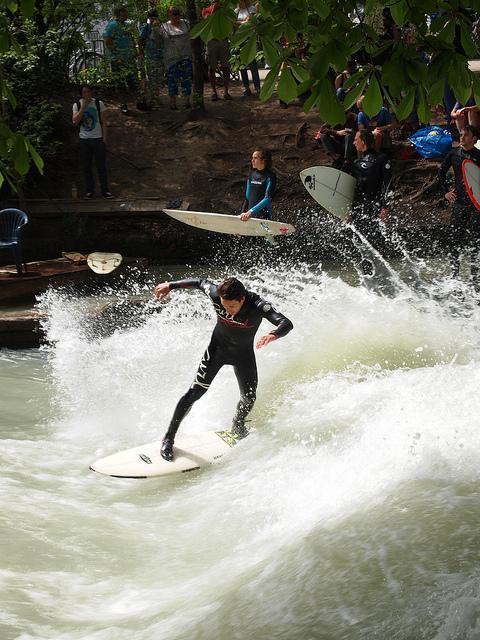Why is he standing like that?
Select the correct answer and articulate reasoning with the following format: 'Answer: answer
Rationale: rationale.'
Options: Falling, tired, slipping, maintain balance. Answer: maintain balance.
Rationale: The other options don't match what he's doing. 